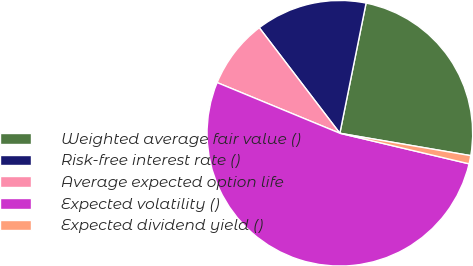<chart> <loc_0><loc_0><loc_500><loc_500><pie_chart><fcel>Weighted average fair value ()<fcel>Risk-free interest rate ()<fcel>Average expected option life<fcel>Expected volatility ()<fcel>Expected dividend yield ()<nl><fcel>24.53%<fcel>13.54%<fcel>8.39%<fcel>52.53%<fcel>1.0%<nl></chart> 